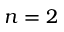Convert formula to latex. <formula><loc_0><loc_0><loc_500><loc_500>n = 2</formula> 